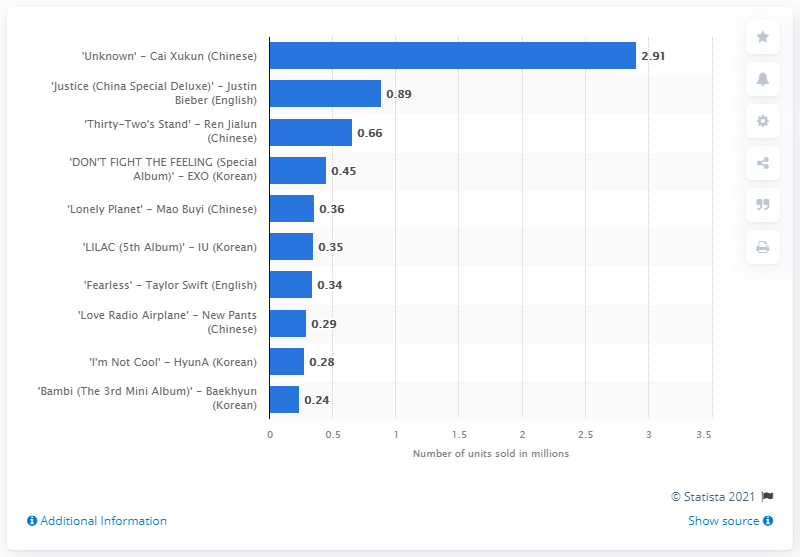Give some essential details in this illustration. In 2021, Cai Xukun sold a total of 2,910 copies of his works. 